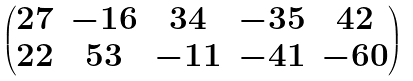Convert formula to latex. <formula><loc_0><loc_0><loc_500><loc_500>\begin{pmatrix} 2 7 & - 1 6 & 3 4 & - 3 5 & 4 2 \\ 2 2 & 5 3 & - 1 1 & - 4 1 & - 6 0 \end{pmatrix}</formula> 